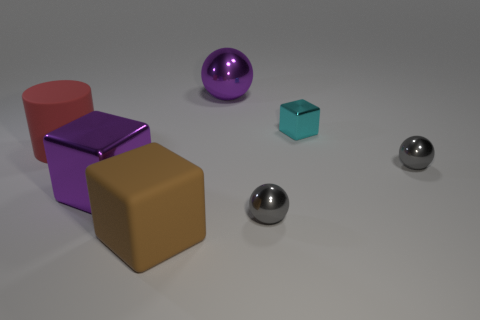There is a shiny block that is the same color as the big ball; what is its size?
Offer a terse response. Large. There is a big metal thing to the left of the matte block; is it the same color as the large rubber thing that is in front of the red matte object?
Offer a terse response. No. How many objects are cubes or large purple spheres?
Keep it short and to the point. 4. How many other things are the same shape as the brown rubber thing?
Your answer should be compact. 2. Is the big purple object that is to the left of the big brown matte object made of the same material as the ball that is behind the small cyan metallic block?
Provide a succinct answer. Yes. There is a big thing that is behind the big shiny block and in front of the large sphere; what is its shape?
Your answer should be compact. Cylinder. Is there any other thing that is the same material as the cyan object?
Keep it short and to the point. Yes. There is a thing that is to the left of the tiny cyan thing and behind the red cylinder; what is its material?
Offer a very short reply. Metal. There is a red object that is made of the same material as the brown object; what is its shape?
Give a very brief answer. Cylinder. Is there any other thing that has the same color as the cylinder?
Your answer should be compact. No. 